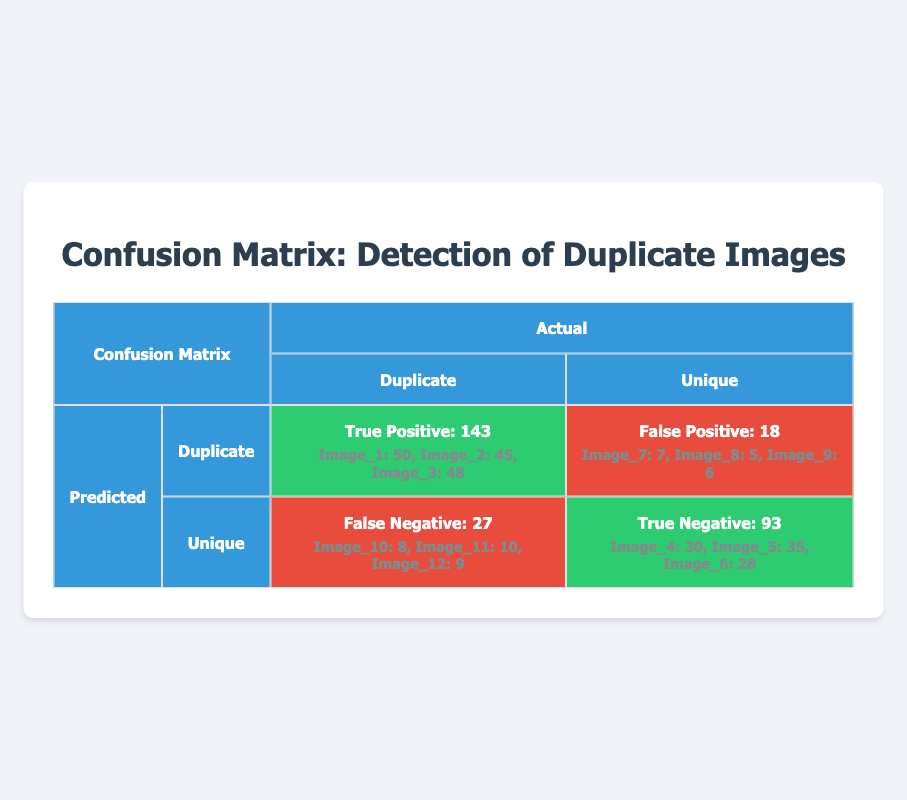What is the total number of true positives in the detection of duplicate images? The true positives are listed in the table as Image_1, Image_2, and Image_3. Their values are 50, 45, and 48, respectively. Adding these values together gives 50 + 45 + 48 = 143.
Answer: 143 How many false negatives are there in total? The false negatives are represented by Image_10, Image_11, and Image_12, with values of 8, 10, and 9. Summing these values results in 8 + 10 + 9 = 27.
Answer: 27 Are there more true negatives or false positives? True negatives for Image_4, Image_5, and Image_6 sum up to 30 + 35 + 28 = 93. False positives for Image_7, Image_8, and Image_9 sum up to 7 + 5 + 6 = 18. Since 93 is greater than 18, true negatives are higher.
Answer: Yes What percentage of images were accurately detected as duplicates (true positives) compared to all images predicted as duplicates? True positives are 143, and false positives are 18. First, add these to get the total predicted as duplicates: 143 + 18 = 161. The percentage of true positives is (143 / 161) * 100 = approximately 88.79%.
Answer: 88.79% If we want to improve the accuracy, what is the current false negative rate? Currently, the false negatives total 27, and to find the false negative rate, we need to consider the total actual duplicates: true positives (143) + false negatives (27) = 170 duplicates. Thus the false negative rate is 27 / 170 = 0.1588 or about 15.88%.
Answer: 15.88% 